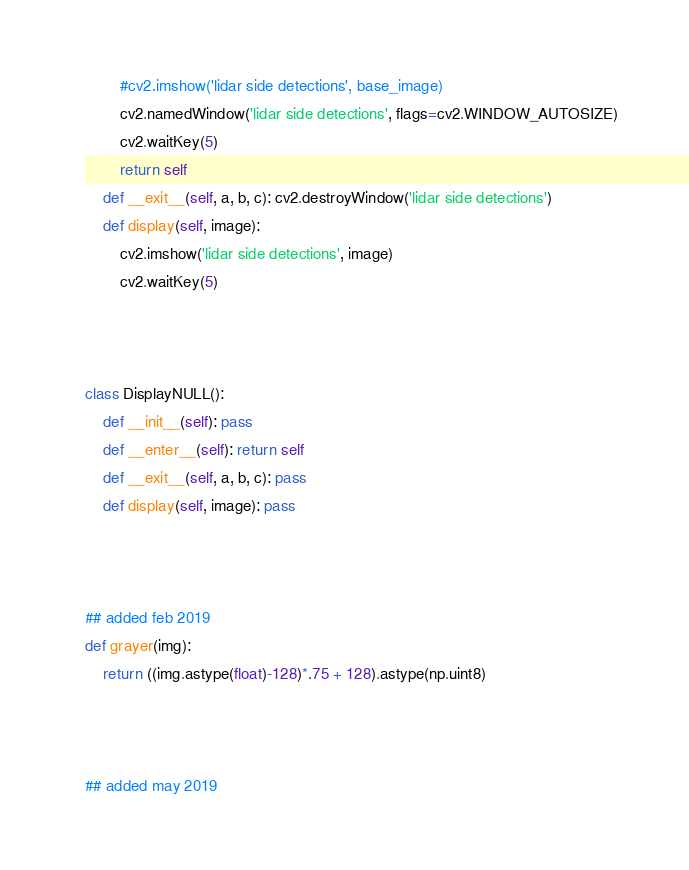<code> <loc_0><loc_0><loc_500><loc_500><_Python_>        #cv2.imshow('lidar side detections', base_image)
        cv2.namedWindow('lidar side detections', flags=cv2.WINDOW_AUTOSIZE)
        cv2.waitKey(5)
        return self
    def __exit__(self, a, b, c): cv2.destroyWindow('lidar side detections')
    def display(self, image):
        cv2.imshow('lidar side detections', image)
        cv2.waitKey(5)
        
        
        
class DisplayNULL():
    def __init__(self): pass
    def __enter__(self): return self
    def __exit__(self, a, b, c): pass
    def display(self, image): pass



## added feb 2019
def grayer(img):
    return ((img.astype(float)-128)*.75 + 128).astype(np.uint8)



## added may 2019</code> 